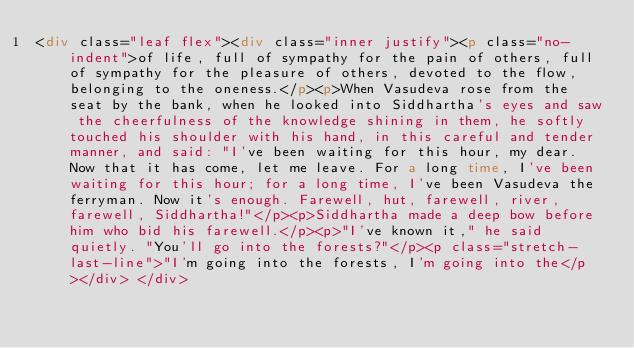<code> <loc_0><loc_0><loc_500><loc_500><_HTML_><div class="leaf flex"><div class="inner justify"><p class="no-indent">of life, full of sympathy for the pain of others, full of sympathy for the pleasure of others, devoted to the flow, belonging to the oneness.</p><p>When Vasudeva rose from the seat by the bank, when he looked into Siddhartha's eyes and saw the cheerfulness of the knowledge shining in them, he softly touched his shoulder with his hand, in this careful and tender manner, and said: "I've been waiting for this hour, my dear. Now that it has come, let me leave. For a long time, I've been waiting for this hour; for a long time, I've been Vasudeva the ferryman. Now it's enough. Farewell, hut, farewell, river, farewell, Siddhartha!"</p><p>Siddhartha made a deep bow before him who bid his farewell.</p><p>"I've known it," he said quietly. "You'll go into the forests?"</p><p class="stretch-last-line">"I'm going into the forests, I'm going into the</p></div> </div></code> 